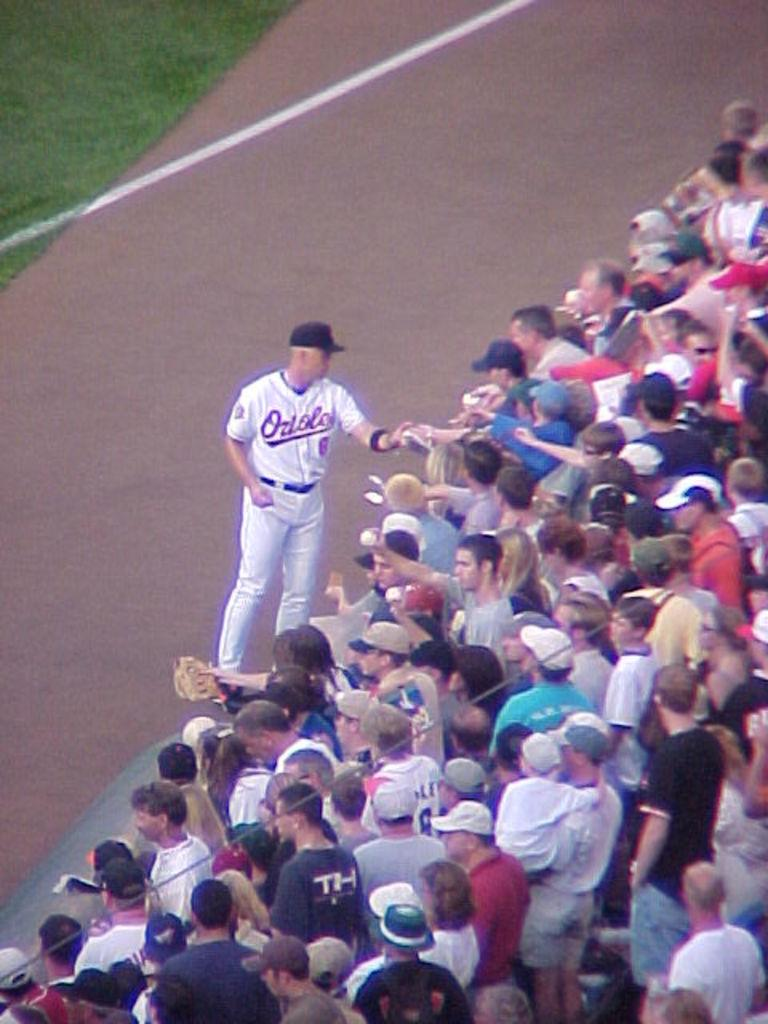What is the main subject of the image? The main subject of the image is a crowd. Is there anyone standing in front of the crowd? Yes, there is a person standing in front of the crowd. What is the person wearing? The person is wearing a cap. What type of surface can be seen in the left side corner of the image? There is grass visible in the left side corner of the image. What type of wall can be seen behind the person in the image? There is no wall visible behind the person in the image; it is a crowd with grass in the corner. 